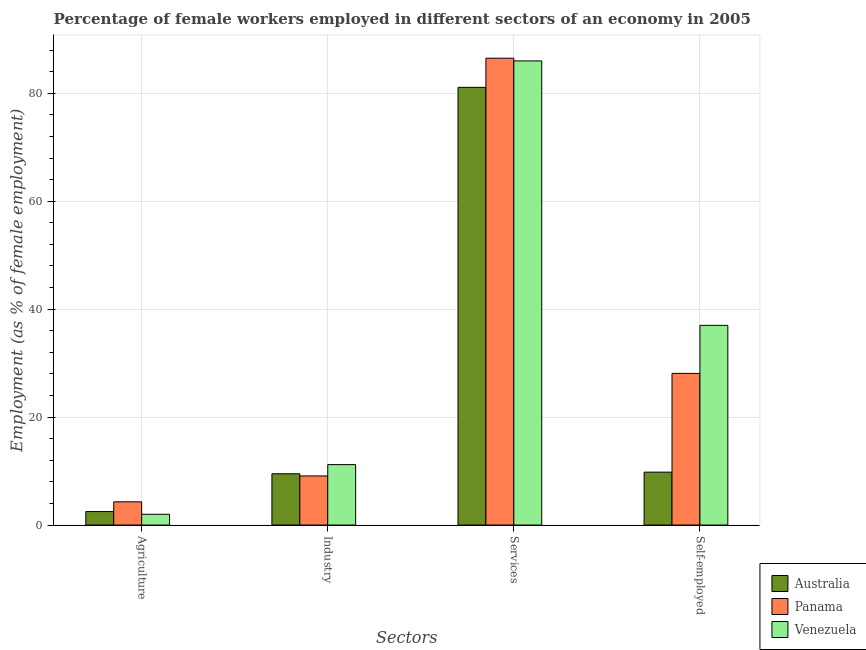How many groups of bars are there?
Give a very brief answer. 4. Are the number of bars per tick equal to the number of legend labels?
Your answer should be very brief. Yes. How many bars are there on the 2nd tick from the right?
Make the answer very short. 3. What is the label of the 1st group of bars from the left?
Provide a succinct answer. Agriculture. What is the percentage of female workers in industry in Australia?
Your answer should be compact. 9.5. Across all countries, what is the maximum percentage of female workers in industry?
Make the answer very short. 11.2. Across all countries, what is the minimum percentage of self employed female workers?
Offer a very short reply. 9.8. In which country was the percentage of female workers in agriculture maximum?
Provide a short and direct response. Panama. In which country was the percentage of female workers in agriculture minimum?
Keep it short and to the point. Venezuela. What is the total percentage of female workers in industry in the graph?
Provide a short and direct response. 29.8. What is the difference between the percentage of female workers in agriculture in Venezuela and that in Australia?
Your answer should be very brief. -0.5. What is the average percentage of female workers in services per country?
Offer a terse response. 84.53. What is the difference between the percentage of female workers in agriculture and percentage of female workers in industry in Venezuela?
Your answer should be very brief. -9.2. What is the ratio of the percentage of female workers in services in Panama to that in Australia?
Your response must be concise. 1.07. Is the percentage of self employed female workers in Panama less than that in Australia?
Keep it short and to the point. No. Is the difference between the percentage of female workers in services in Venezuela and Panama greater than the difference between the percentage of female workers in industry in Venezuela and Panama?
Your response must be concise. No. What is the difference between the highest and the second highest percentage of female workers in industry?
Ensure brevity in your answer.  1.7. What is the difference between the highest and the lowest percentage of self employed female workers?
Offer a very short reply. 27.2. Is it the case that in every country, the sum of the percentage of self employed female workers and percentage of female workers in agriculture is greater than the sum of percentage of female workers in services and percentage of female workers in industry?
Provide a succinct answer. No. What does the 3rd bar from the left in Services represents?
Your answer should be very brief. Venezuela. What does the 1st bar from the right in Services represents?
Offer a terse response. Venezuela. Is it the case that in every country, the sum of the percentage of female workers in agriculture and percentage of female workers in industry is greater than the percentage of female workers in services?
Make the answer very short. No. Are all the bars in the graph horizontal?
Your answer should be very brief. No. How many countries are there in the graph?
Give a very brief answer. 3. What is the difference between two consecutive major ticks on the Y-axis?
Keep it short and to the point. 20. Does the graph contain any zero values?
Give a very brief answer. No. How many legend labels are there?
Offer a very short reply. 3. How are the legend labels stacked?
Your answer should be very brief. Vertical. What is the title of the graph?
Provide a succinct answer. Percentage of female workers employed in different sectors of an economy in 2005. Does "Lesotho" appear as one of the legend labels in the graph?
Provide a short and direct response. No. What is the label or title of the X-axis?
Ensure brevity in your answer.  Sectors. What is the label or title of the Y-axis?
Provide a succinct answer. Employment (as % of female employment). What is the Employment (as % of female employment) in Australia in Agriculture?
Provide a short and direct response. 2.5. What is the Employment (as % of female employment) of Panama in Agriculture?
Provide a short and direct response. 4.3. What is the Employment (as % of female employment) of Venezuela in Agriculture?
Your answer should be very brief. 2. What is the Employment (as % of female employment) in Panama in Industry?
Make the answer very short. 9.1. What is the Employment (as % of female employment) in Venezuela in Industry?
Your response must be concise. 11.2. What is the Employment (as % of female employment) of Australia in Services?
Provide a succinct answer. 81.1. What is the Employment (as % of female employment) of Panama in Services?
Give a very brief answer. 86.5. What is the Employment (as % of female employment) of Australia in Self-employed?
Provide a succinct answer. 9.8. What is the Employment (as % of female employment) of Panama in Self-employed?
Give a very brief answer. 28.1. What is the Employment (as % of female employment) of Venezuela in Self-employed?
Give a very brief answer. 37. Across all Sectors, what is the maximum Employment (as % of female employment) in Australia?
Give a very brief answer. 81.1. Across all Sectors, what is the maximum Employment (as % of female employment) of Panama?
Provide a short and direct response. 86.5. Across all Sectors, what is the minimum Employment (as % of female employment) in Panama?
Keep it short and to the point. 4.3. Across all Sectors, what is the minimum Employment (as % of female employment) of Venezuela?
Offer a terse response. 2. What is the total Employment (as % of female employment) of Australia in the graph?
Your response must be concise. 102.9. What is the total Employment (as % of female employment) in Panama in the graph?
Your response must be concise. 128. What is the total Employment (as % of female employment) in Venezuela in the graph?
Your response must be concise. 136.2. What is the difference between the Employment (as % of female employment) of Australia in Agriculture and that in Industry?
Your response must be concise. -7. What is the difference between the Employment (as % of female employment) in Australia in Agriculture and that in Services?
Provide a short and direct response. -78.6. What is the difference between the Employment (as % of female employment) in Panama in Agriculture and that in Services?
Provide a short and direct response. -82.2. What is the difference between the Employment (as % of female employment) of Venezuela in Agriculture and that in Services?
Ensure brevity in your answer.  -84. What is the difference between the Employment (as % of female employment) of Panama in Agriculture and that in Self-employed?
Your answer should be very brief. -23.8. What is the difference between the Employment (as % of female employment) of Venezuela in Agriculture and that in Self-employed?
Provide a succinct answer. -35. What is the difference between the Employment (as % of female employment) in Australia in Industry and that in Services?
Offer a terse response. -71.6. What is the difference between the Employment (as % of female employment) of Panama in Industry and that in Services?
Your answer should be very brief. -77.4. What is the difference between the Employment (as % of female employment) of Venezuela in Industry and that in Services?
Make the answer very short. -74.8. What is the difference between the Employment (as % of female employment) of Australia in Industry and that in Self-employed?
Your answer should be very brief. -0.3. What is the difference between the Employment (as % of female employment) of Venezuela in Industry and that in Self-employed?
Provide a short and direct response. -25.8. What is the difference between the Employment (as % of female employment) of Australia in Services and that in Self-employed?
Offer a terse response. 71.3. What is the difference between the Employment (as % of female employment) of Panama in Services and that in Self-employed?
Make the answer very short. 58.4. What is the difference between the Employment (as % of female employment) of Australia in Agriculture and the Employment (as % of female employment) of Panama in Industry?
Your answer should be very brief. -6.6. What is the difference between the Employment (as % of female employment) in Australia in Agriculture and the Employment (as % of female employment) in Venezuela in Industry?
Your answer should be compact. -8.7. What is the difference between the Employment (as % of female employment) in Panama in Agriculture and the Employment (as % of female employment) in Venezuela in Industry?
Your answer should be compact. -6.9. What is the difference between the Employment (as % of female employment) in Australia in Agriculture and the Employment (as % of female employment) in Panama in Services?
Give a very brief answer. -84. What is the difference between the Employment (as % of female employment) of Australia in Agriculture and the Employment (as % of female employment) of Venezuela in Services?
Your answer should be compact. -83.5. What is the difference between the Employment (as % of female employment) of Panama in Agriculture and the Employment (as % of female employment) of Venezuela in Services?
Your answer should be very brief. -81.7. What is the difference between the Employment (as % of female employment) in Australia in Agriculture and the Employment (as % of female employment) in Panama in Self-employed?
Ensure brevity in your answer.  -25.6. What is the difference between the Employment (as % of female employment) in Australia in Agriculture and the Employment (as % of female employment) in Venezuela in Self-employed?
Provide a short and direct response. -34.5. What is the difference between the Employment (as % of female employment) in Panama in Agriculture and the Employment (as % of female employment) in Venezuela in Self-employed?
Your answer should be very brief. -32.7. What is the difference between the Employment (as % of female employment) of Australia in Industry and the Employment (as % of female employment) of Panama in Services?
Offer a very short reply. -77. What is the difference between the Employment (as % of female employment) in Australia in Industry and the Employment (as % of female employment) in Venezuela in Services?
Ensure brevity in your answer.  -76.5. What is the difference between the Employment (as % of female employment) in Panama in Industry and the Employment (as % of female employment) in Venezuela in Services?
Your answer should be very brief. -76.9. What is the difference between the Employment (as % of female employment) of Australia in Industry and the Employment (as % of female employment) of Panama in Self-employed?
Keep it short and to the point. -18.6. What is the difference between the Employment (as % of female employment) of Australia in Industry and the Employment (as % of female employment) of Venezuela in Self-employed?
Make the answer very short. -27.5. What is the difference between the Employment (as % of female employment) of Panama in Industry and the Employment (as % of female employment) of Venezuela in Self-employed?
Keep it short and to the point. -27.9. What is the difference between the Employment (as % of female employment) of Australia in Services and the Employment (as % of female employment) of Venezuela in Self-employed?
Provide a short and direct response. 44.1. What is the difference between the Employment (as % of female employment) in Panama in Services and the Employment (as % of female employment) in Venezuela in Self-employed?
Provide a short and direct response. 49.5. What is the average Employment (as % of female employment) of Australia per Sectors?
Ensure brevity in your answer.  25.73. What is the average Employment (as % of female employment) of Venezuela per Sectors?
Ensure brevity in your answer.  34.05. What is the difference between the Employment (as % of female employment) in Australia and Employment (as % of female employment) in Panama in Agriculture?
Keep it short and to the point. -1.8. What is the difference between the Employment (as % of female employment) in Australia and Employment (as % of female employment) in Panama in Industry?
Give a very brief answer. 0.4. What is the difference between the Employment (as % of female employment) of Australia and Employment (as % of female employment) of Venezuela in Industry?
Your answer should be very brief. -1.7. What is the difference between the Employment (as % of female employment) in Australia and Employment (as % of female employment) in Panama in Services?
Your response must be concise. -5.4. What is the difference between the Employment (as % of female employment) in Australia and Employment (as % of female employment) in Venezuela in Services?
Make the answer very short. -4.9. What is the difference between the Employment (as % of female employment) in Australia and Employment (as % of female employment) in Panama in Self-employed?
Keep it short and to the point. -18.3. What is the difference between the Employment (as % of female employment) of Australia and Employment (as % of female employment) of Venezuela in Self-employed?
Make the answer very short. -27.2. What is the ratio of the Employment (as % of female employment) of Australia in Agriculture to that in Industry?
Provide a succinct answer. 0.26. What is the ratio of the Employment (as % of female employment) of Panama in Agriculture to that in Industry?
Your answer should be compact. 0.47. What is the ratio of the Employment (as % of female employment) of Venezuela in Agriculture to that in Industry?
Your response must be concise. 0.18. What is the ratio of the Employment (as % of female employment) in Australia in Agriculture to that in Services?
Your answer should be compact. 0.03. What is the ratio of the Employment (as % of female employment) in Panama in Agriculture to that in Services?
Keep it short and to the point. 0.05. What is the ratio of the Employment (as % of female employment) in Venezuela in Agriculture to that in Services?
Make the answer very short. 0.02. What is the ratio of the Employment (as % of female employment) of Australia in Agriculture to that in Self-employed?
Offer a very short reply. 0.26. What is the ratio of the Employment (as % of female employment) in Panama in Agriculture to that in Self-employed?
Offer a very short reply. 0.15. What is the ratio of the Employment (as % of female employment) in Venezuela in Agriculture to that in Self-employed?
Provide a short and direct response. 0.05. What is the ratio of the Employment (as % of female employment) of Australia in Industry to that in Services?
Keep it short and to the point. 0.12. What is the ratio of the Employment (as % of female employment) of Panama in Industry to that in Services?
Offer a terse response. 0.11. What is the ratio of the Employment (as % of female employment) in Venezuela in Industry to that in Services?
Provide a short and direct response. 0.13. What is the ratio of the Employment (as % of female employment) of Australia in Industry to that in Self-employed?
Offer a very short reply. 0.97. What is the ratio of the Employment (as % of female employment) in Panama in Industry to that in Self-employed?
Offer a terse response. 0.32. What is the ratio of the Employment (as % of female employment) of Venezuela in Industry to that in Self-employed?
Offer a terse response. 0.3. What is the ratio of the Employment (as % of female employment) of Australia in Services to that in Self-employed?
Your answer should be compact. 8.28. What is the ratio of the Employment (as % of female employment) of Panama in Services to that in Self-employed?
Provide a succinct answer. 3.08. What is the ratio of the Employment (as % of female employment) in Venezuela in Services to that in Self-employed?
Ensure brevity in your answer.  2.32. What is the difference between the highest and the second highest Employment (as % of female employment) of Australia?
Your answer should be compact. 71.3. What is the difference between the highest and the second highest Employment (as % of female employment) of Panama?
Ensure brevity in your answer.  58.4. What is the difference between the highest and the lowest Employment (as % of female employment) in Australia?
Make the answer very short. 78.6. What is the difference between the highest and the lowest Employment (as % of female employment) in Panama?
Make the answer very short. 82.2. What is the difference between the highest and the lowest Employment (as % of female employment) of Venezuela?
Ensure brevity in your answer.  84. 